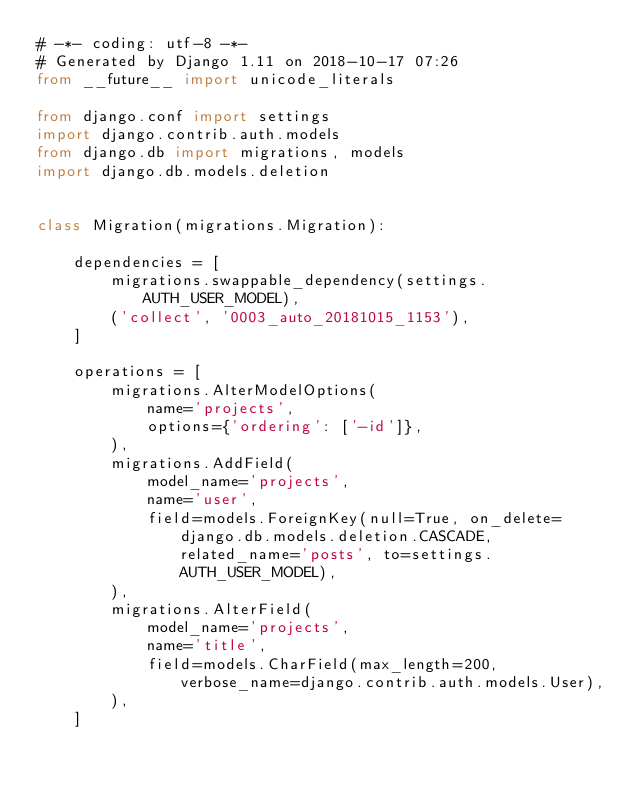<code> <loc_0><loc_0><loc_500><loc_500><_Python_># -*- coding: utf-8 -*-
# Generated by Django 1.11 on 2018-10-17 07:26
from __future__ import unicode_literals

from django.conf import settings
import django.contrib.auth.models
from django.db import migrations, models
import django.db.models.deletion


class Migration(migrations.Migration):

    dependencies = [
        migrations.swappable_dependency(settings.AUTH_USER_MODEL),
        ('collect', '0003_auto_20181015_1153'),
    ]

    operations = [
        migrations.AlterModelOptions(
            name='projects',
            options={'ordering': ['-id']},
        ),
        migrations.AddField(
            model_name='projects',
            name='user',
            field=models.ForeignKey(null=True, on_delete=django.db.models.deletion.CASCADE, related_name='posts', to=settings.AUTH_USER_MODEL),
        ),
        migrations.AlterField(
            model_name='projects',
            name='title',
            field=models.CharField(max_length=200, verbose_name=django.contrib.auth.models.User),
        ),
    ]
</code> 